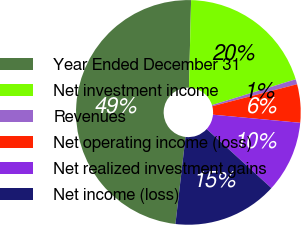Convert chart. <chart><loc_0><loc_0><loc_500><loc_500><pie_chart><fcel>Year Ended December 31<fcel>Net investment income<fcel>Revenues<fcel>Net operating income (loss)<fcel>Net realized investment gains<fcel>Net income (loss)<nl><fcel>48.55%<fcel>19.85%<fcel>0.73%<fcel>5.51%<fcel>10.29%<fcel>15.07%<nl></chart> 